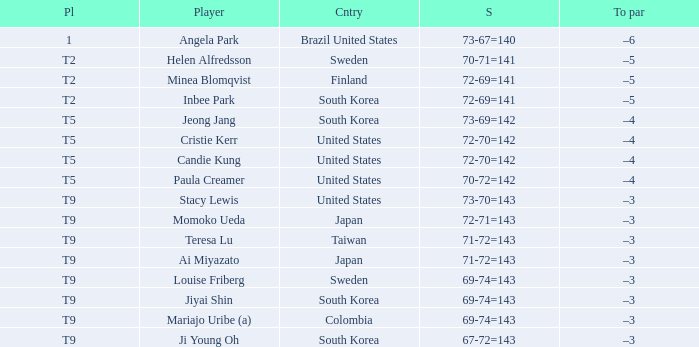Which country placed t9 and had the player jiyai shin? South Korea. 